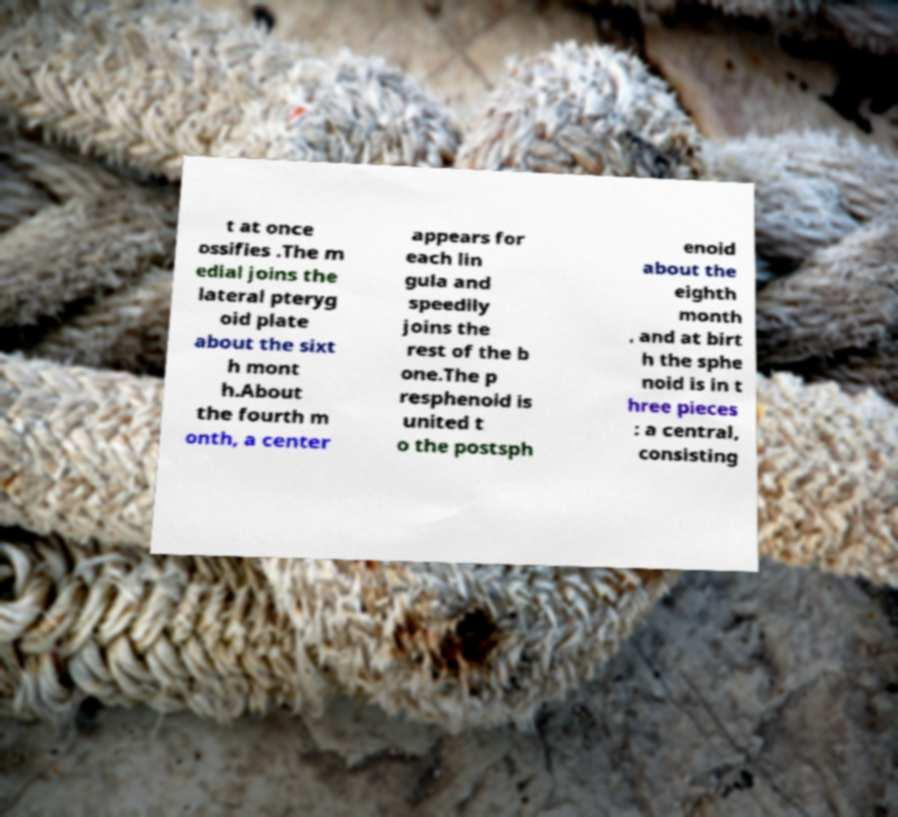Could you extract and type out the text from this image? t at once ossifies .The m edial joins the lateral pteryg oid plate about the sixt h mont h.About the fourth m onth, a center appears for each lin gula and speedily joins the rest of the b one.The p resphenoid is united t o the postsph enoid about the eighth month , and at birt h the sphe noid is in t hree pieces : a central, consisting 